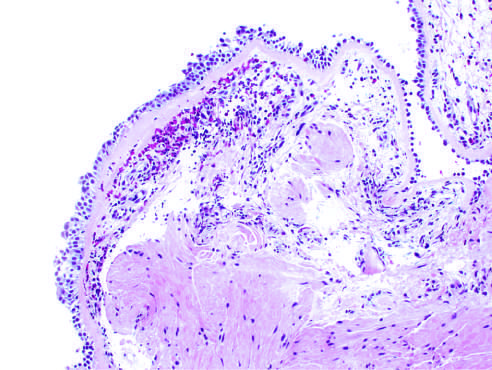what does the bronchial biopsy specimen from the asthmatic patient show?
Answer the question using a single word or phrase. Sub-basement membrane fibrosis 